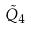Convert formula to latex. <formula><loc_0><loc_0><loc_500><loc_500>\tilde { Q } _ { 4 }</formula> 